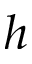Convert formula to latex. <formula><loc_0><loc_0><loc_500><loc_500>h</formula> 